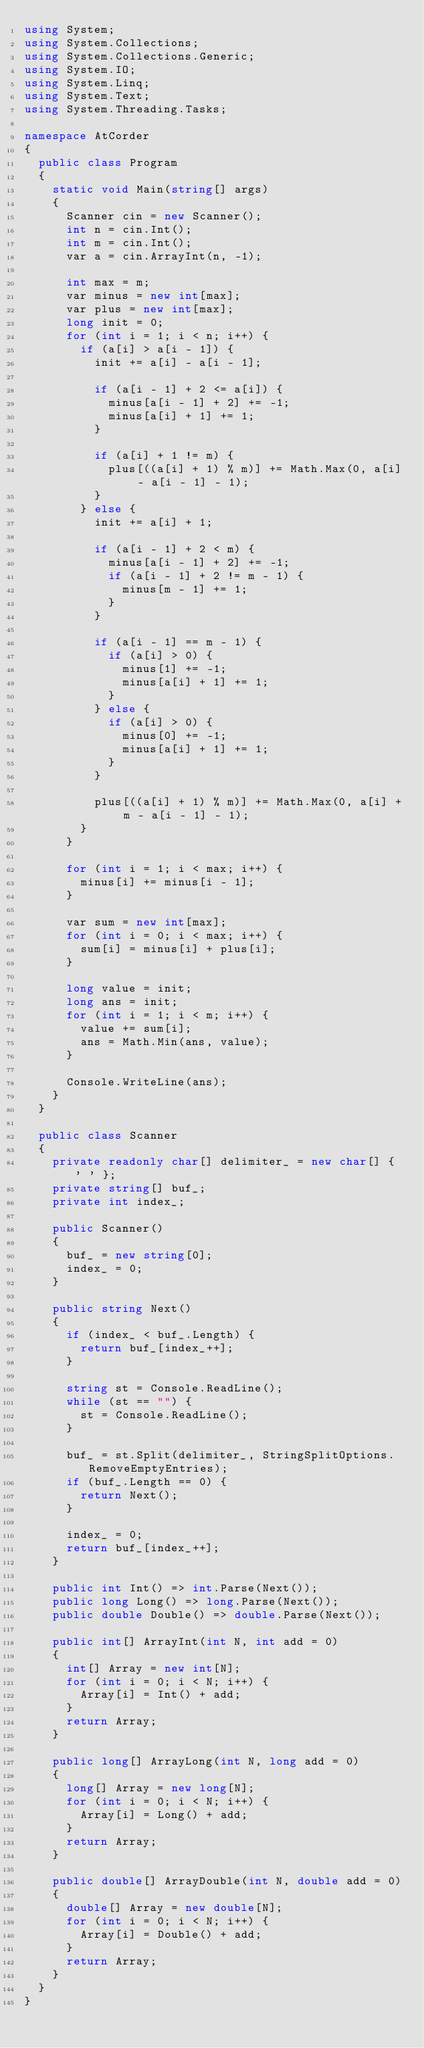Convert code to text. <code><loc_0><loc_0><loc_500><loc_500><_C#_>using System;
using System.Collections;
using System.Collections.Generic;
using System.IO;
using System.Linq;
using System.Text;
using System.Threading.Tasks;

namespace AtCorder
{
	public class Program
	{
		static void Main(string[] args)
		{
			Scanner cin = new Scanner();
			int n = cin.Int();
			int m = cin.Int();
			var a = cin.ArrayInt(n, -1);

			int max = m;
			var minus = new int[max];
			var plus = new int[max];
			long init = 0;
			for (int i = 1; i < n; i++) {
				if (a[i] > a[i - 1]) {
					init += a[i] - a[i - 1];

					if (a[i - 1] + 2 <= a[i]) {
						minus[a[i - 1] + 2] += -1;
						minus[a[i] + 1] += 1;
					}

					if (a[i] + 1 != m) {
						plus[((a[i] + 1) % m)] += Math.Max(0, a[i] - a[i - 1] - 1);
					}
				} else {
					init += a[i] + 1;

					if (a[i - 1] + 2 < m) {
						minus[a[i - 1] + 2] += -1;
						if (a[i - 1] + 2 != m - 1) {
							minus[m - 1] += 1;
						}
					}

					if (a[i - 1] == m - 1) {
						if (a[i] > 0) {
							minus[1] += -1;
							minus[a[i] + 1] += 1;
						}
					} else {
						if (a[i] > 0) {
							minus[0] += -1;
							minus[a[i] + 1] += 1;
						}
					}

					plus[((a[i] + 1) % m)] += Math.Max(0, a[i] + m - a[i - 1] - 1);
				}
			}

			for (int i = 1; i < max; i++) {
				minus[i] += minus[i - 1];
			}

			var sum = new int[max];
			for (int i = 0; i < max; i++) {
				sum[i] = minus[i] + plus[i];
			}

			long value = init;
			long ans = init;
			for (int i = 1; i < m; i++) {
				value += sum[i];
				ans = Math.Min(ans, value);
			}

			Console.WriteLine(ans);
		}
	}

	public class Scanner
	{
		private readonly char[] delimiter_ = new char[] { ' ' };
		private string[] buf_;
		private int index_;

		public Scanner()
		{
			buf_ = new string[0];
			index_ = 0;
		}

		public string Next()
		{
			if (index_ < buf_.Length) {
				return buf_[index_++];
			}

			string st = Console.ReadLine();
			while (st == "") {
				st = Console.ReadLine();
			}

			buf_ = st.Split(delimiter_, StringSplitOptions.RemoveEmptyEntries);
			if (buf_.Length == 0) {
				return Next();
			}

			index_ = 0;
			return buf_[index_++];
		}

		public int Int() => int.Parse(Next());
		public long Long() => long.Parse(Next());
		public double Double() => double.Parse(Next());

		public int[] ArrayInt(int N, int add = 0)
		{
			int[] Array = new int[N];
			for (int i = 0; i < N; i++) {
				Array[i] = Int() + add;
			}
			return Array;
		}

		public long[] ArrayLong(int N, long add = 0)
		{
			long[] Array = new long[N];
			for (int i = 0; i < N; i++) {
				Array[i] = Long() + add;
			}
			return Array;
		}

		public double[] ArrayDouble(int N, double add = 0)
		{
			double[] Array = new double[N];
			for (int i = 0; i < N; i++) {
				Array[i] = Double() + add;
			}
			return Array;
		}
	}
}</code> 